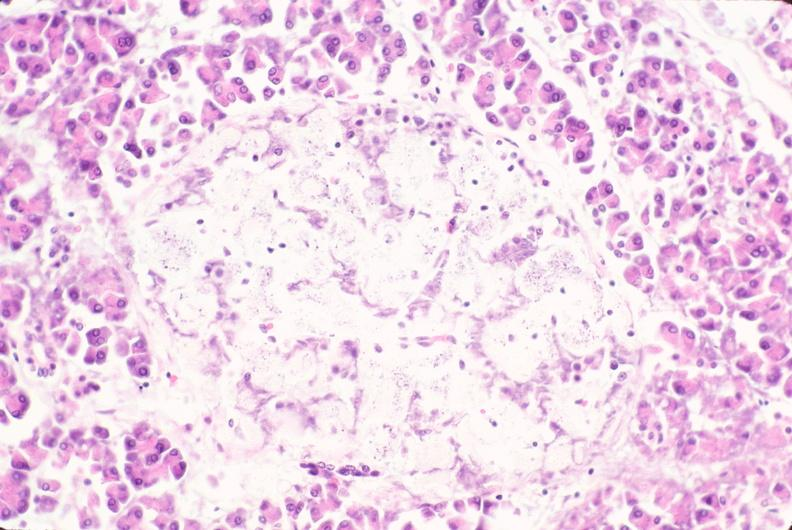where is this part in the figure?
Answer the question using a single word or phrase. Endocrine system 